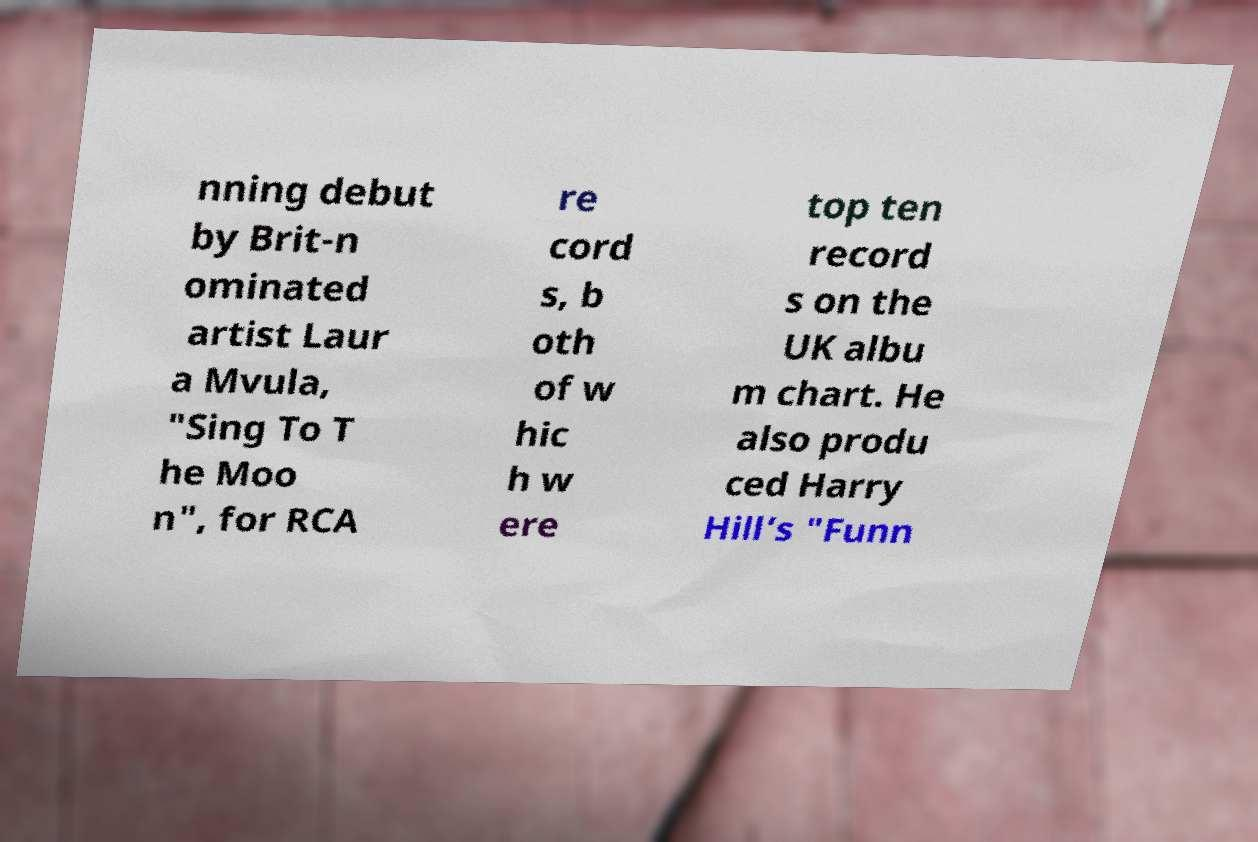Please identify and transcribe the text found in this image. nning debut by Brit-n ominated artist Laur a Mvula, "Sing To T he Moo n", for RCA re cord s, b oth of w hic h w ere top ten record s on the UK albu m chart. He also produ ced Harry Hill’s "Funn 